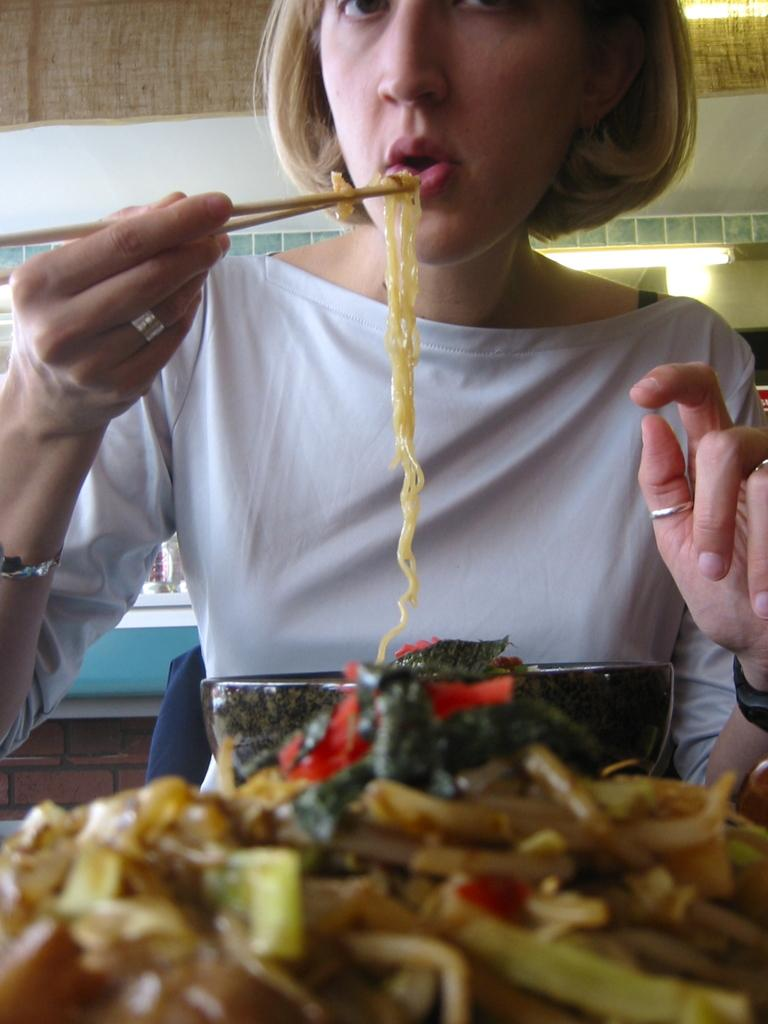What is the woman holding in the image? The woman is holding chopsticks with noodles. What can be seen in front of the woman? There are food items in front of the woman. What is visible in the background of the image? There is a wall in the background of the image. What type of accessories is the woman wearing? The woman is wearing rings, a bracelet, and a watch. Can you see a kitten playing with a squirrel in the sleet in the image? No, there is no kitten, squirrel, or sleet present in the image. 